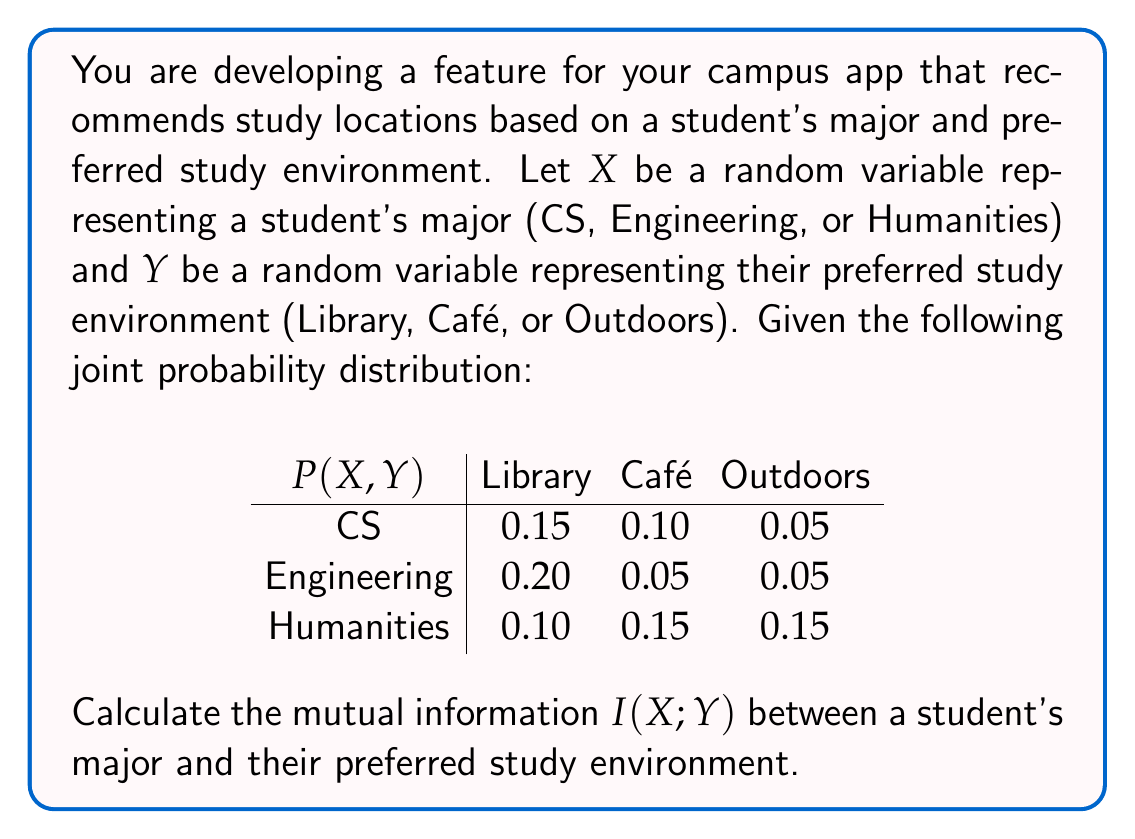Solve this math problem. To calculate the mutual information $I(X;Y)$, we'll follow these steps:

1) First, we need to calculate the marginal probabilities $P(X)$ and $P(Y)$:

   $P(X = \text{CS}) = 0.15 + 0.10 + 0.05 = 0.30$
   $P(X = \text{Engineering}) = 0.20 + 0.05 + 0.05 = 0.30$
   $P(X = \text{Humanities}) = 0.10 + 0.15 + 0.15 = 0.40$

   $P(Y = \text{Library}) = 0.15 + 0.20 + 0.10 = 0.45$
   $P(Y = \text{Café}) = 0.10 + 0.05 + 0.15 = 0.30$
   $P(Y = \text{Outdoors}) = 0.05 + 0.05 + 0.15 = 0.25$

2) The formula for mutual information is:

   $$I(X;Y) = \sum_{x \in X} \sum_{y \in Y} P(x,y) \log_2 \frac{P(x,y)}{P(x)P(y)}$$

3) Now, we calculate each term of the sum:

   For CS, Library: $0.15 \log_2 \frac{0.15}{0.30 \cdot 0.45} = 0.15 \log_2 1.11 = 0.0228$
   For CS, Café: $0.10 \log_2 \frac{0.10}{0.30 \cdot 0.30} = 0.10 \log_2 1.11 = 0.0152$
   For CS, Outdoors: $0.05 \log_2 \frac{0.05}{0.30 \cdot 0.25} = 0.05 \log_2 0.67 = -0.0249$

   For Engineering, Library: $0.20 \log_2 \frac{0.20}{0.30 \cdot 0.45} = 0.20 \log_2 1.48 = 0.0944$
   For Engineering, Café: $0.05 \log_2 \frac{0.05}{0.30 \cdot 0.30} = 0.05 \log_2 0.56 = -0.0391$
   For Engineering, Outdoors: $0.05 \log_2 \frac{0.05}{0.30 \cdot 0.25} = 0.05 \log_2 0.67 = -0.0249$

   For Humanities, Library: $0.10 \log_2 \frac{0.10}{0.40 \cdot 0.45} = 0.10 \log_2 0.56 = -0.0782$
   For Humanities, Café: $0.15 \log_2 \frac{0.15}{0.40 \cdot 0.30} = 0.15 \log_2 1.25 = 0.0452$
   For Humanities, Outdoors: $0.15 \log_2 \frac{0.15}{0.40 \cdot 0.25} = 0.15 \log_2 1.50 = 0.0849$

4) Sum all these terms:

   $I(X;Y) = 0.0228 + 0.0152 - 0.0249 + 0.0944 - 0.0391 - 0.0249 - 0.0782 + 0.0452 + 0.0849 = 0.0954$

Thus, the mutual information $I(X;Y)$ is approximately 0.0954 bits.
Answer: $I(X;Y) \approx 0.0954$ bits 